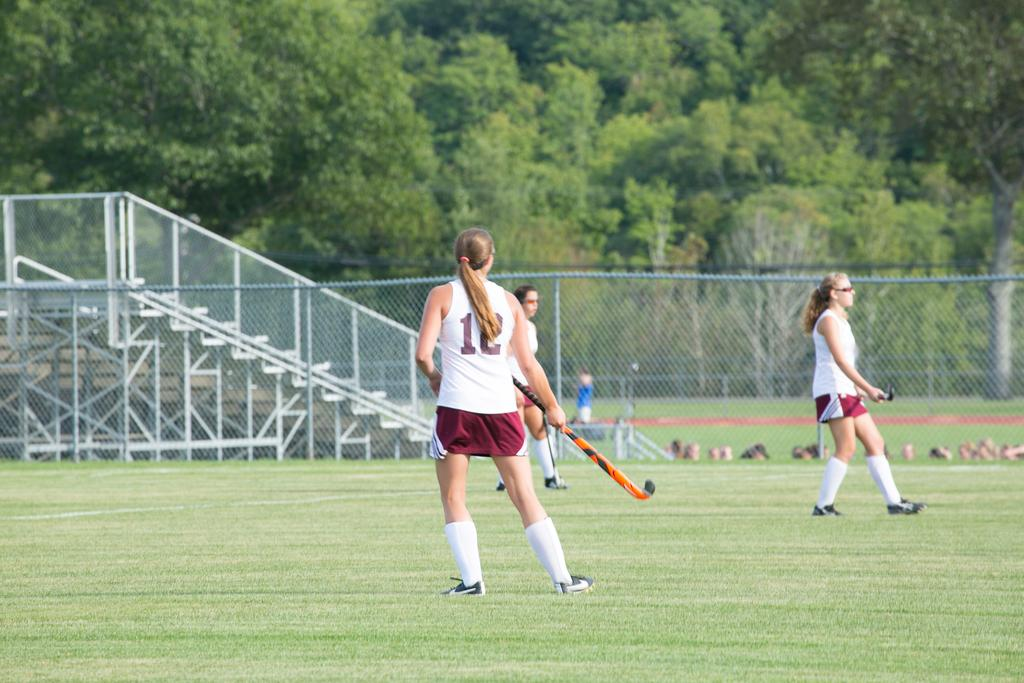What activity are the girls engaged in within the image? The girls are playing hockey in the image. What type of surface are they playing on? There is a ground in the image where they are playing. What is the purpose of the fence in the image? The fence is present in the image to enclose the area where the girls are playing hockey. What additional architectural feature can be seen in the image? There are iron stairs in the image. What natural elements are visible in the image? There are trees in the image. What type of cushion is being used to protect the girls while they play hockey in the image? There is no cushion present in the image; the girls are playing hockey on a ground without any protective padding. 